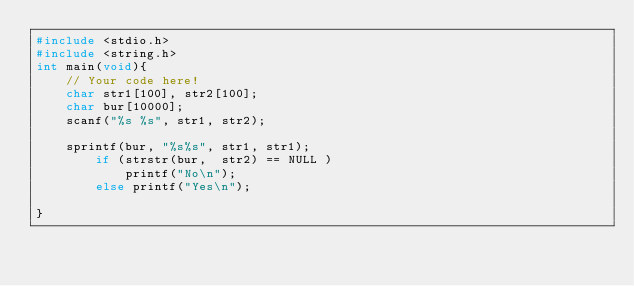<code> <loc_0><loc_0><loc_500><loc_500><_C_>#include <stdio.h>
#include <string.h>
int main(void){
    // Your code here!
    char str1[100], str2[100];
    char bur[10000];
    scanf("%s %s", str1, str2);
    
    sprintf(bur, "%s%s", str1, str1);
        if (strstr(bur,  str2) == NULL )
            printf("No\n");
        else printf("Yes\n");

}

</code> 